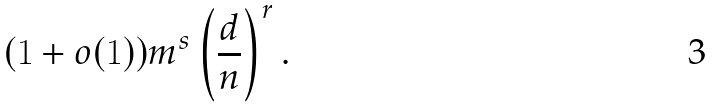<formula> <loc_0><loc_0><loc_500><loc_500>( 1 + o ( 1 ) ) m ^ { s } \left ( \frac { d } { n } \right ) ^ { r } .</formula> 